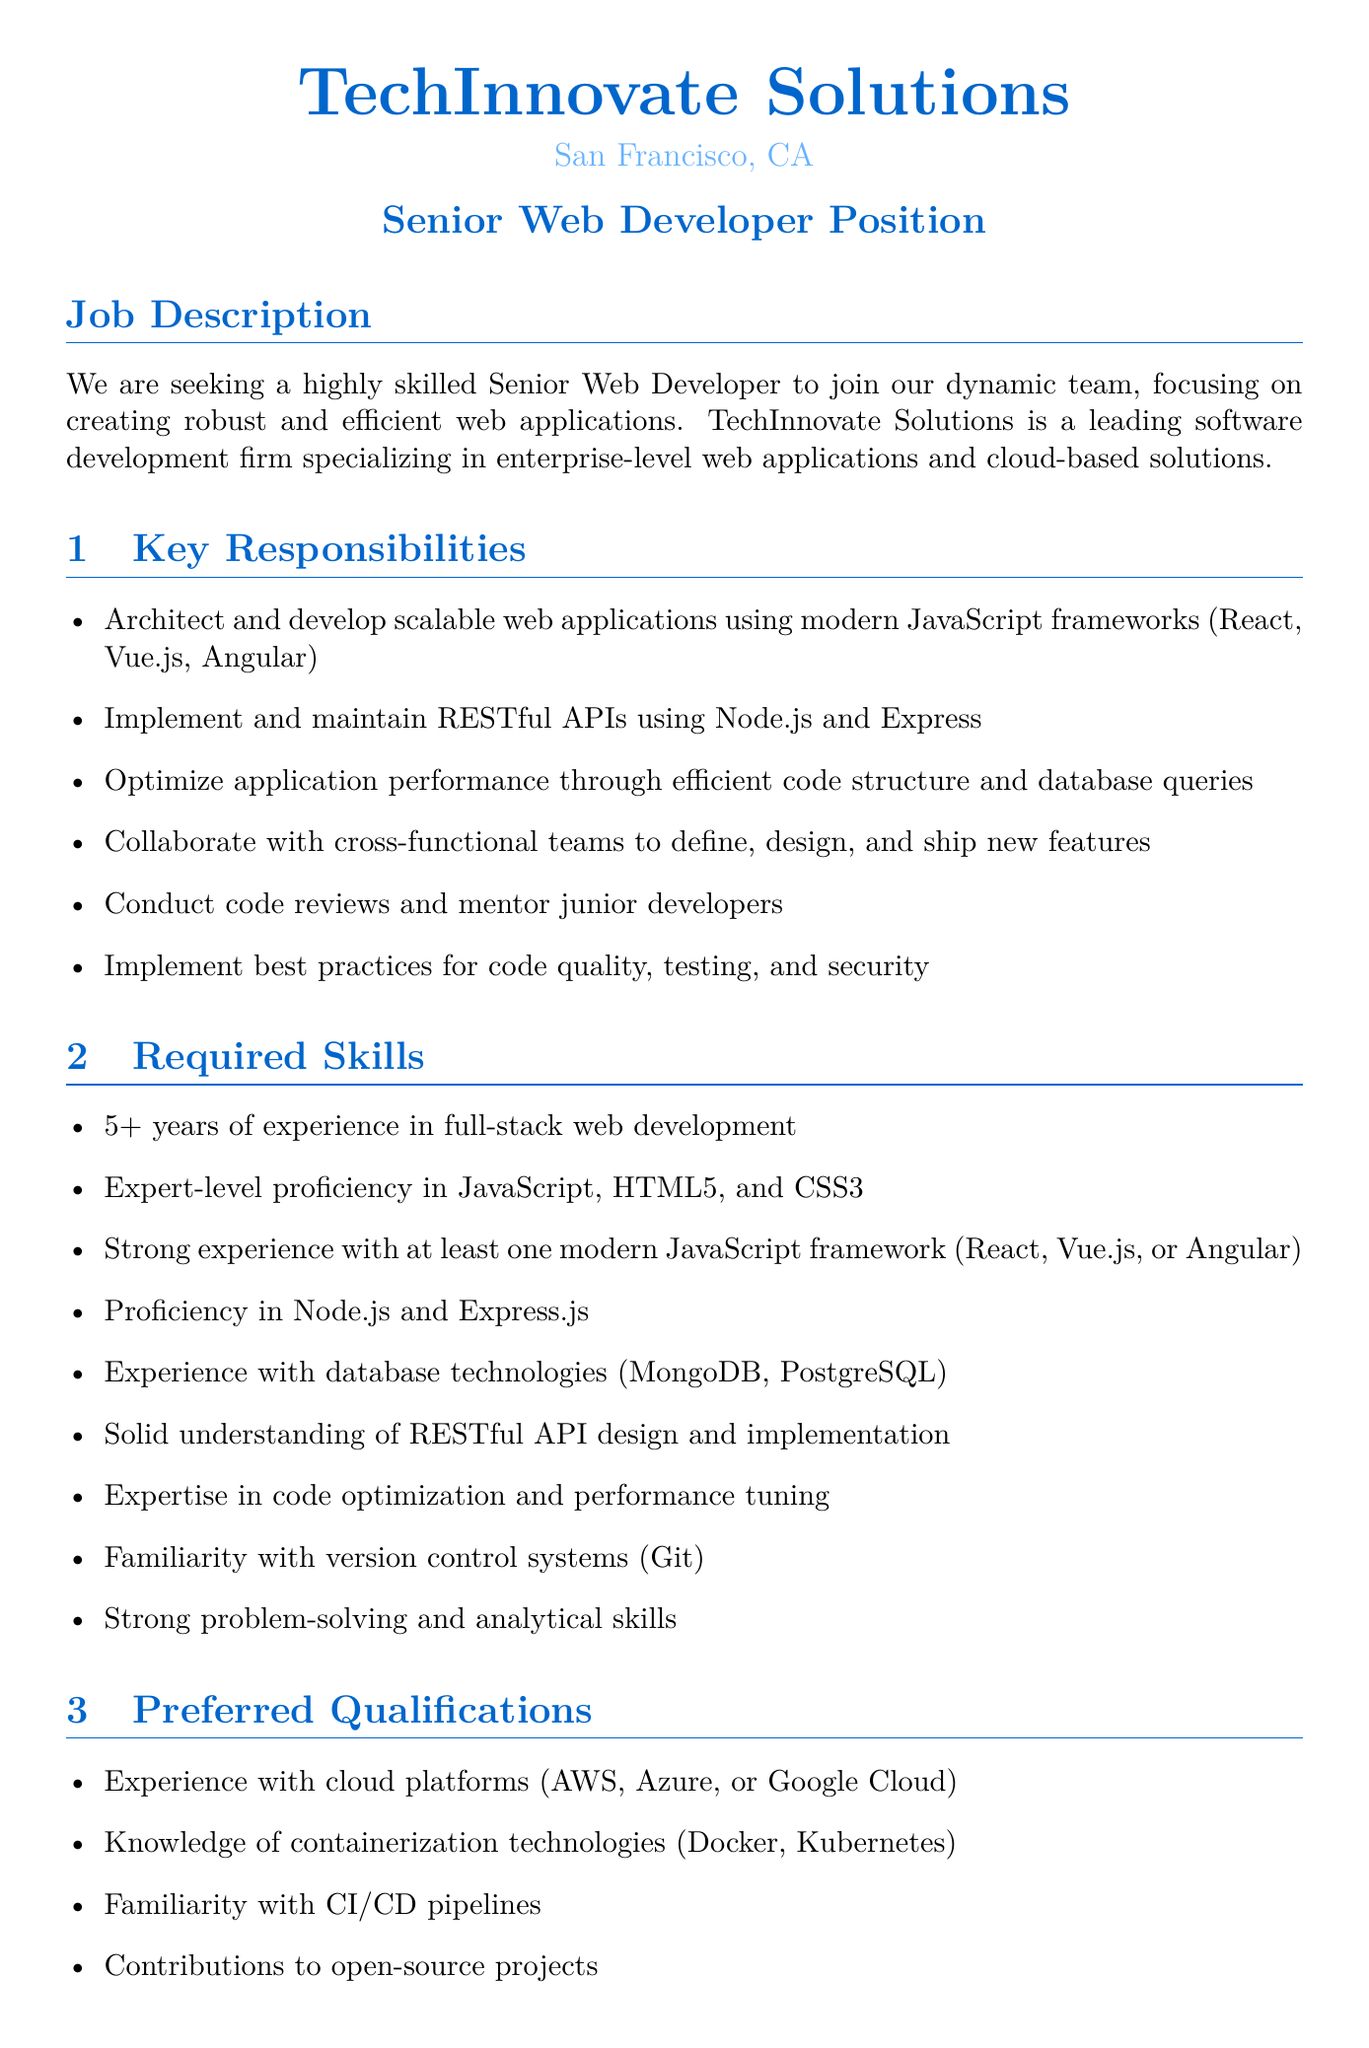What is the job title? The job title is explicitly mentioned in the document under the heading "Senior Web Developer Position."
Answer: Senior Web Developer What is the location of TechInnovate Solutions? The document explicitly states the location of TechInnovate Solutions as San Francisco, CA.
Answer: San Francisco, CA How many years of experience are required for the position? The document indicates that 5+ years of experience in full-stack web development is required.
Answer: 5+ What is the salary range offered for the position? The salary range is specifically mentioned in the "Compensation and Benefits" section of the document.
Answer: $120,000 - $160,000 per year What percentage of equity is offered to the employee? The document states the equity offered is between 0.5% - 1% of company shares.
Answer: 0.5% - 1% What are the key responsibilities of the role? The responsibilities include architecting applications and optimizing performance, as outlined in the "Key Responsibilities" section.
Answer: Architect and develop scalable web applications using modern JavaScript frameworks What is one of the preferred qualifications? The document lists several preferred qualifications, and any can be used as an answer; one is sufficient.
Answer: Experience with cloud platforms What is the timeline for the application process? The timeline for the application process is provided in the "Application Process" section.
Answer: 2-3 weeks Who is the contact person for the job offer? The contact person's name and title are provided at the end of the document.
Answer: Emily Chen, Technical Recruiting Manager 